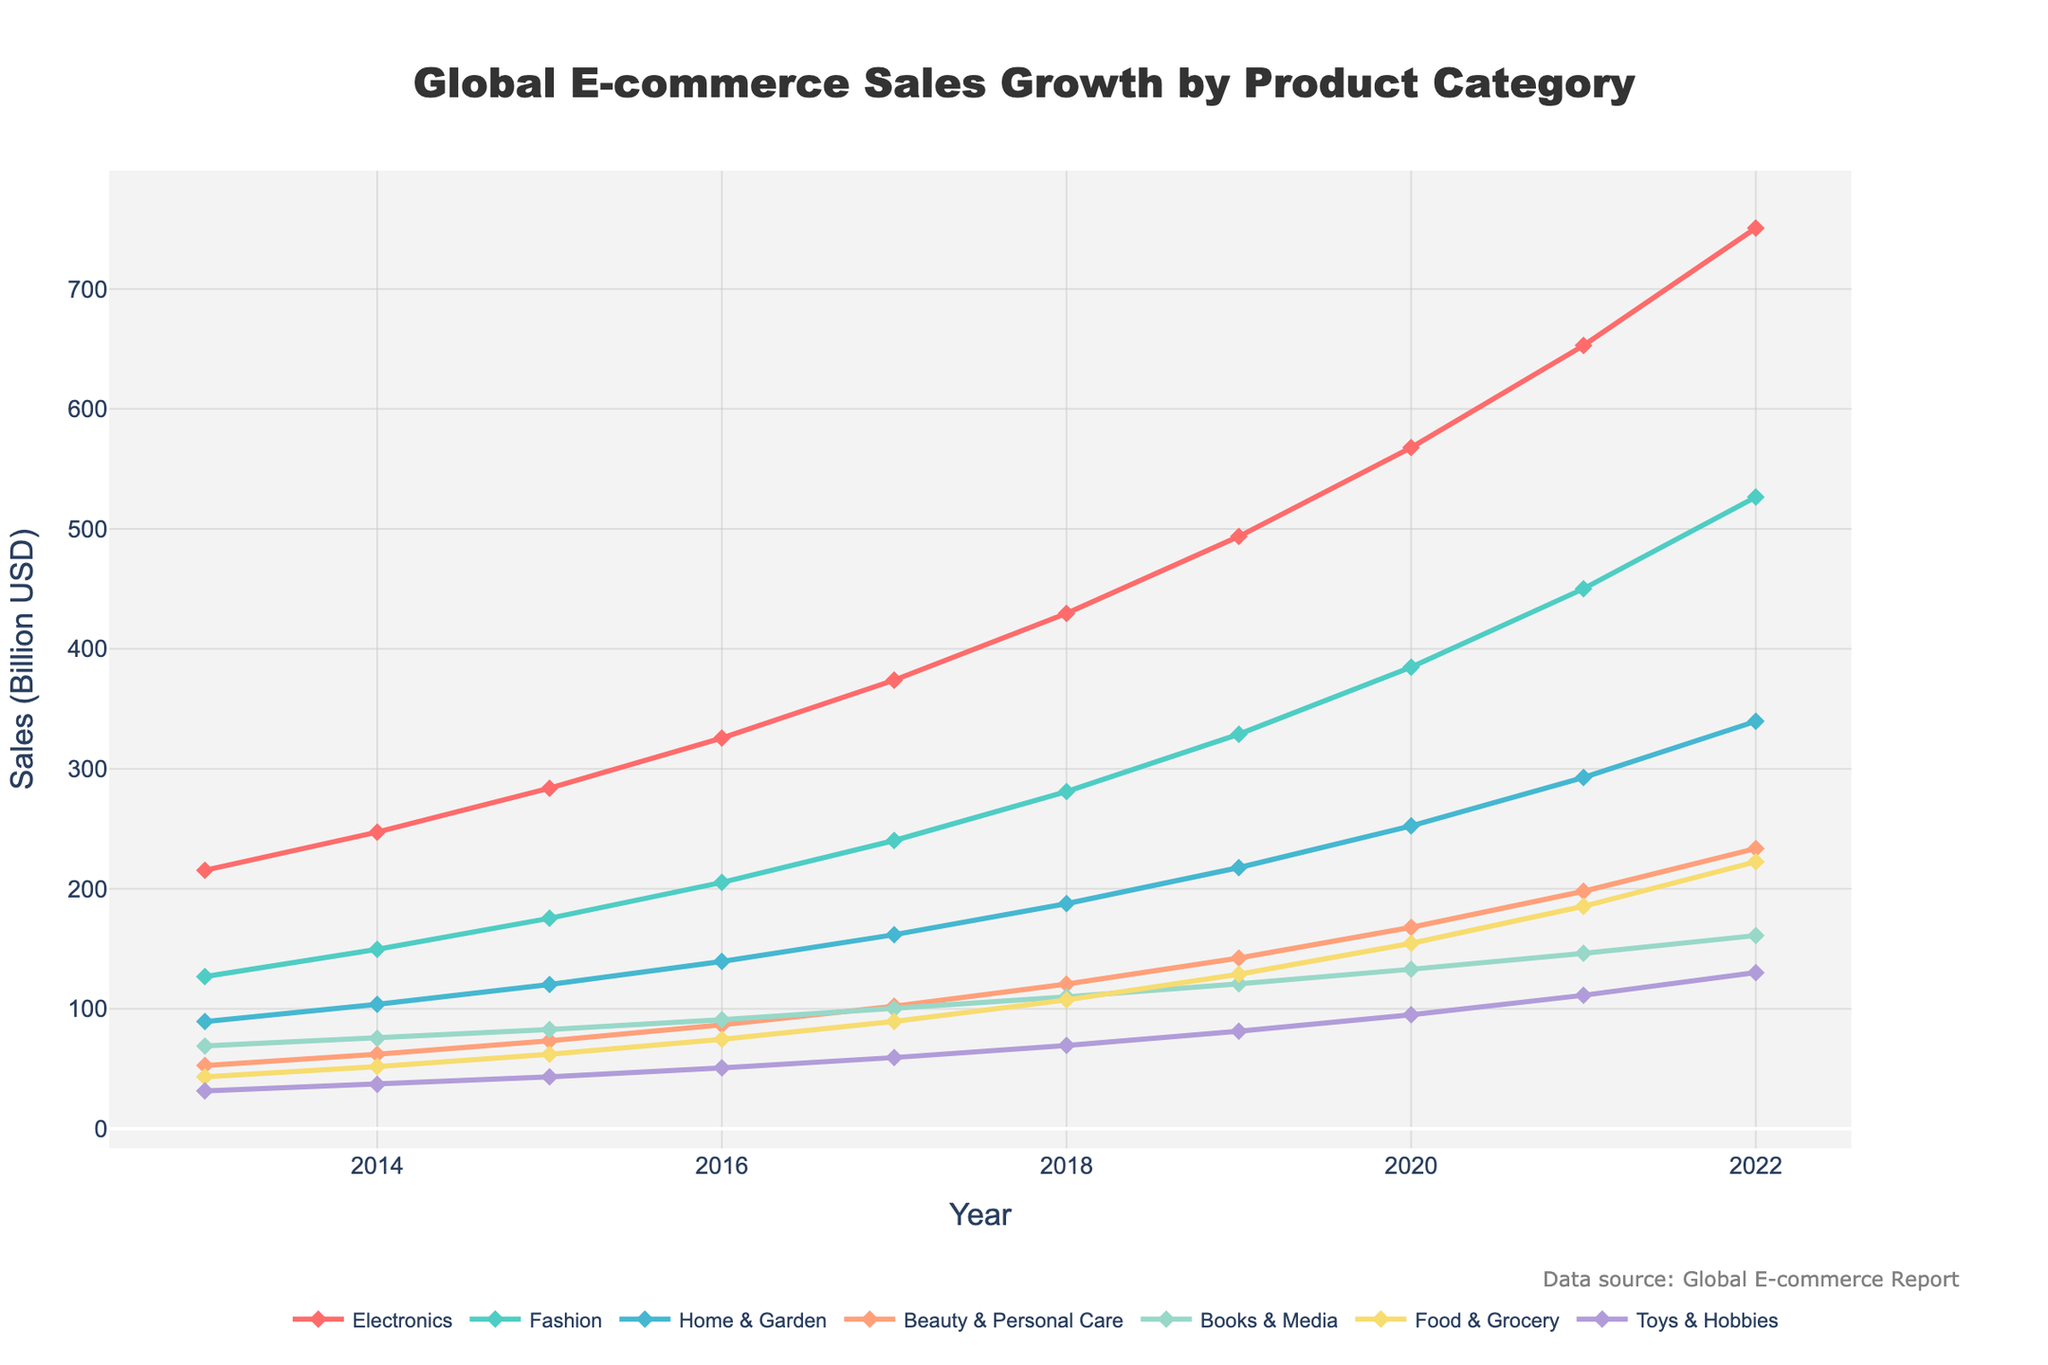What is the overall trend in the Electronics category over the past decade? The figure shows a steady increase in sales for the Electronics category from 215.4 billion USD in 2013 to 750.8 billion USD in 2022. This indicates a consistent upward trend over the decade.
Answer: Steady increase Which product category experienced the highest growth between 2013 and 2022? By comparing the beginning and end values for each category, the Electronics category grew from 215.4 billion USD in 2013 to 750.8 billion USD in 2022, an increase of 535.4 billion USD, which is the largest among all categories.
Answer: Electronics What is the sum of sales for Beauty & Personal Care and Food & Grocery in 2020? From the figure, Beauty & Personal Care sales in 2020 were 167.8 billion USD, and Food & Grocery sales were 154.5 billion USD. Adding these together: 167.8 + 154.5 = 322.3 billion USD.
Answer: 322.3 billion USD Which category had the smallest increase in sales from 2013 to 2022? By comparing the difference between the 2013 and 2022 values for each category, the Books & Media category grew from 68.9 billion USD in 2013 to 161.0 billion USD in 2022, an increase of 92.1 billion USD, which is the smallest growth increment.
Answer: Books & Media In what year did the Toys & Hobbies category sales surpass the 50 billion USD mark? Observing the Toys & Hobbies curve on the chart, sales surpassed the 50 billion USD mark in the year 2016 when they reached 50.7 billion USD.
Answer: 2016 How do the 2022 sales of Home & Garden compare to the 2022 sales of Fashion? According to the chart, Home & Garden sales in 2022 were 339.6 billion USD, while Fashion sales were 526.6 billion USD. Thus, Fashion sales were significantly higher than Home & Garden sales in 2022.
Answer: Fashion sales are higher What was the average annual increase in Electronics sales from 2013 to 2022? The Electronics sales increased from 215.4 billion USD in 2013 to 750.8 billion USD in 2022, a total increase of 750.8 - 215.4 = 535.4 billion USD over 9 years. The average annual increase is 535.4 / 9 ≈ 59.49 billion USD.
Answer: Approximately 59.49 billion USD per year Which year showed the highest growth in Food & Grocery sales compared to the previous year? By examining the year-over-year changes in Food & Grocery sales on the chart, the highest growth occurred between 2021 and 2022, where the sales increased from 185.4 to 222.5 billion USD, a growth of 37.1 billion USD.
Answer: 2021 to 2022 Which category saw the most consistent growth across all years? Analyzing the smoothness of the lines on the chart and the uniformity of growth year over year, the Fashion category exhibits the most consistent growth without significant fluctuations.
Answer: Fashion 